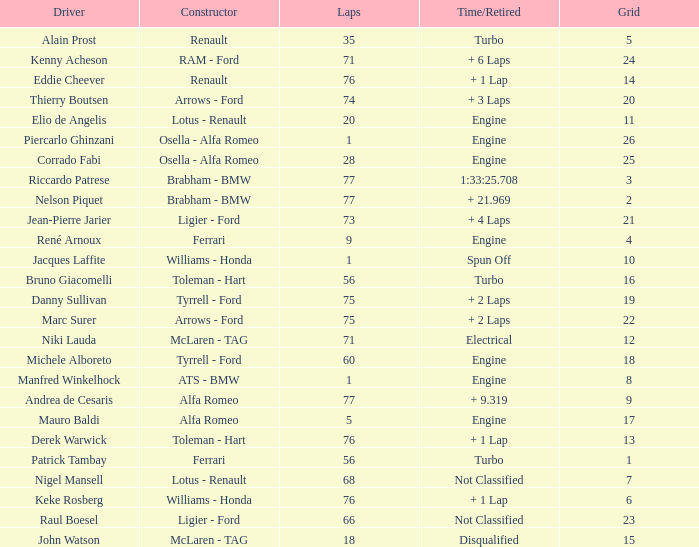Who drove the grid 10 car? Jacques Laffite. 